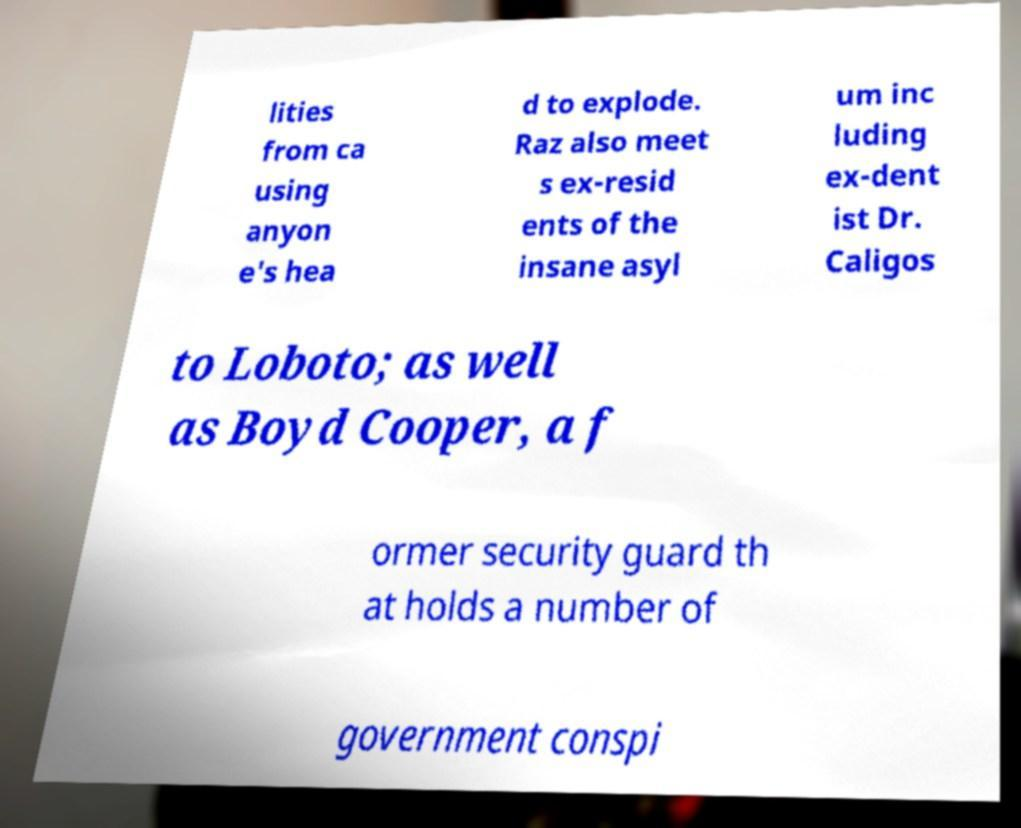Can you read and provide the text displayed in the image?This photo seems to have some interesting text. Can you extract and type it out for me? lities from ca using anyon e's hea d to explode. Raz also meet s ex-resid ents of the insane asyl um inc luding ex-dent ist Dr. Caligos to Loboto; as well as Boyd Cooper, a f ormer security guard th at holds a number of government conspi 